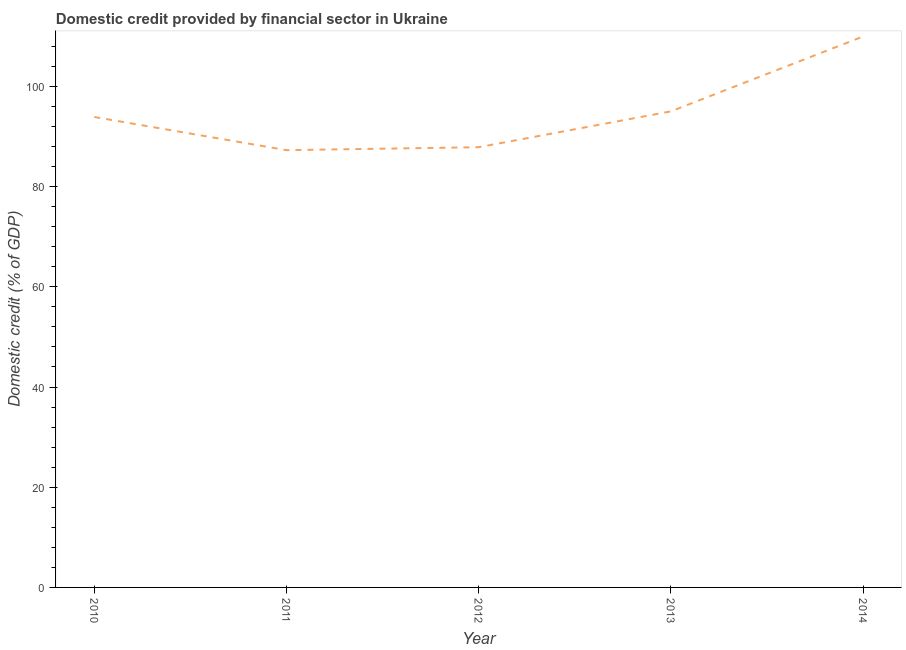What is the domestic credit provided by financial sector in 2011?
Offer a very short reply. 87.27. Across all years, what is the maximum domestic credit provided by financial sector?
Offer a very short reply. 109.96. Across all years, what is the minimum domestic credit provided by financial sector?
Offer a terse response. 87.27. In which year was the domestic credit provided by financial sector maximum?
Ensure brevity in your answer.  2014. In which year was the domestic credit provided by financial sector minimum?
Keep it short and to the point. 2011. What is the sum of the domestic credit provided by financial sector?
Offer a terse response. 474.01. What is the difference between the domestic credit provided by financial sector in 2011 and 2012?
Make the answer very short. -0.59. What is the average domestic credit provided by financial sector per year?
Provide a short and direct response. 94.8. What is the median domestic credit provided by financial sector?
Make the answer very short. 93.89. In how many years, is the domestic credit provided by financial sector greater than 4 %?
Your answer should be compact. 5. Do a majority of the years between 2013 and 2012 (inclusive) have domestic credit provided by financial sector greater than 84 %?
Ensure brevity in your answer.  No. What is the ratio of the domestic credit provided by financial sector in 2010 to that in 2014?
Your response must be concise. 0.85. Is the difference between the domestic credit provided by financial sector in 2013 and 2014 greater than the difference between any two years?
Make the answer very short. No. What is the difference between the highest and the second highest domestic credit provided by financial sector?
Your answer should be compact. 14.94. What is the difference between the highest and the lowest domestic credit provided by financial sector?
Give a very brief answer. 22.68. How many lines are there?
Make the answer very short. 1. How many years are there in the graph?
Ensure brevity in your answer.  5. Does the graph contain any zero values?
Keep it short and to the point. No. What is the title of the graph?
Keep it short and to the point. Domestic credit provided by financial sector in Ukraine. What is the label or title of the Y-axis?
Your response must be concise. Domestic credit (% of GDP). What is the Domestic credit (% of GDP) in 2010?
Provide a succinct answer. 93.89. What is the Domestic credit (% of GDP) in 2011?
Your answer should be very brief. 87.27. What is the Domestic credit (% of GDP) in 2012?
Keep it short and to the point. 87.87. What is the Domestic credit (% of GDP) of 2013?
Provide a short and direct response. 95.02. What is the Domestic credit (% of GDP) in 2014?
Your response must be concise. 109.96. What is the difference between the Domestic credit (% of GDP) in 2010 and 2011?
Your answer should be compact. 6.62. What is the difference between the Domestic credit (% of GDP) in 2010 and 2012?
Make the answer very short. 6.03. What is the difference between the Domestic credit (% of GDP) in 2010 and 2013?
Make the answer very short. -1.12. What is the difference between the Domestic credit (% of GDP) in 2010 and 2014?
Give a very brief answer. -16.06. What is the difference between the Domestic credit (% of GDP) in 2011 and 2012?
Offer a terse response. -0.59. What is the difference between the Domestic credit (% of GDP) in 2011 and 2013?
Your answer should be very brief. -7.74. What is the difference between the Domestic credit (% of GDP) in 2011 and 2014?
Keep it short and to the point. -22.68. What is the difference between the Domestic credit (% of GDP) in 2012 and 2013?
Your response must be concise. -7.15. What is the difference between the Domestic credit (% of GDP) in 2012 and 2014?
Offer a very short reply. -22.09. What is the difference between the Domestic credit (% of GDP) in 2013 and 2014?
Offer a very short reply. -14.94. What is the ratio of the Domestic credit (% of GDP) in 2010 to that in 2011?
Your answer should be compact. 1.08. What is the ratio of the Domestic credit (% of GDP) in 2010 to that in 2012?
Offer a terse response. 1.07. What is the ratio of the Domestic credit (% of GDP) in 2010 to that in 2014?
Your answer should be very brief. 0.85. What is the ratio of the Domestic credit (% of GDP) in 2011 to that in 2012?
Offer a very short reply. 0.99. What is the ratio of the Domestic credit (% of GDP) in 2011 to that in 2013?
Ensure brevity in your answer.  0.92. What is the ratio of the Domestic credit (% of GDP) in 2011 to that in 2014?
Offer a very short reply. 0.79. What is the ratio of the Domestic credit (% of GDP) in 2012 to that in 2013?
Offer a very short reply. 0.93. What is the ratio of the Domestic credit (% of GDP) in 2012 to that in 2014?
Ensure brevity in your answer.  0.8. What is the ratio of the Domestic credit (% of GDP) in 2013 to that in 2014?
Offer a very short reply. 0.86. 